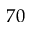<formula> <loc_0><loc_0><loc_500><loc_500>7 0</formula> 